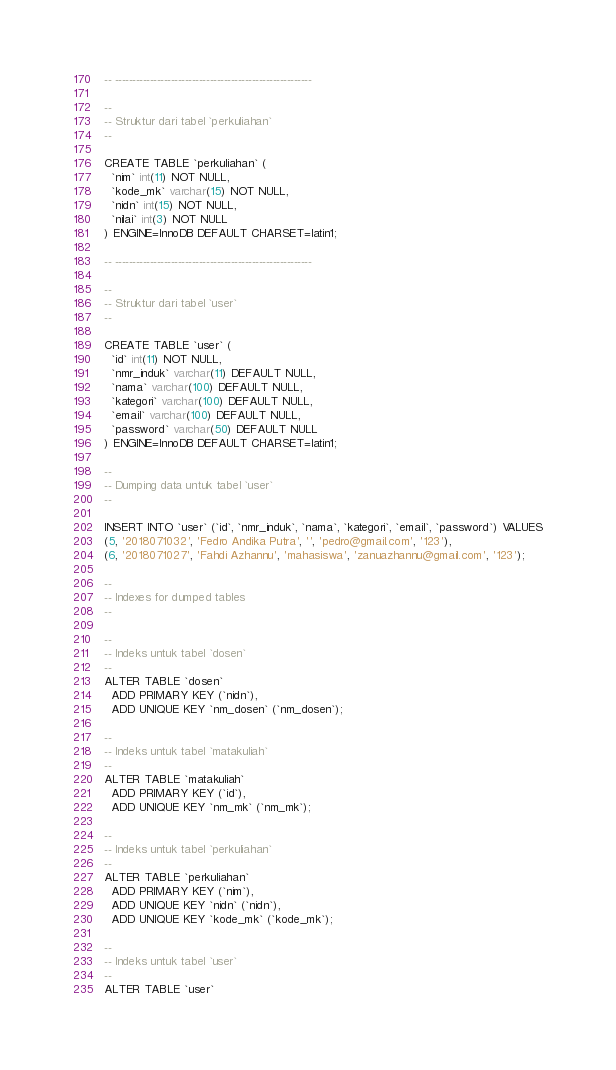Convert code to text. <code><loc_0><loc_0><loc_500><loc_500><_SQL_>-- --------------------------------------------------------

--
-- Struktur dari tabel `perkuliahan`
--

CREATE TABLE `perkuliahan` (
  `nim` int(11) NOT NULL,
  `kode_mk` varchar(15) NOT NULL,
  `nidn` int(15) NOT NULL,
  `nilai` int(3) NOT NULL
) ENGINE=InnoDB DEFAULT CHARSET=latin1;

-- --------------------------------------------------------

--
-- Struktur dari tabel `user`
--

CREATE TABLE `user` (
  `id` int(11) NOT NULL,
  `nmr_induk` varchar(11) DEFAULT NULL,
  `nama` varchar(100) DEFAULT NULL,
  `kategori` varchar(100) DEFAULT NULL,
  `email` varchar(100) DEFAULT NULL,
  `password` varchar(50) DEFAULT NULL
) ENGINE=InnoDB DEFAULT CHARSET=latin1;

--
-- Dumping data untuk tabel `user`
--

INSERT INTO `user` (`id`, `nmr_induk`, `nama`, `kategori`, `email`, `password`) VALUES
(5, '2018071032', 'Fedro Andika Putra', '', 'pedro@gmail.com', '123'),
(6, '2018071027', 'Fahdi Azhannu', 'mahasiswa', 'zanuazhannu@gmail.com', '123');

--
-- Indexes for dumped tables
--

--
-- Indeks untuk tabel `dosen`
--
ALTER TABLE `dosen`
  ADD PRIMARY KEY (`nidn`),
  ADD UNIQUE KEY `nm_dosen` (`nm_dosen`);

--
-- Indeks untuk tabel `matakuliah`
--
ALTER TABLE `matakuliah`
  ADD PRIMARY KEY (`id`),
  ADD UNIQUE KEY `nm_mk` (`nm_mk`);

--
-- Indeks untuk tabel `perkuliahan`
--
ALTER TABLE `perkuliahan`
  ADD PRIMARY KEY (`nim`),
  ADD UNIQUE KEY `nidn` (`nidn`),
  ADD UNIQUE KEY `kode_mk` (`kode_mk`);

--
-- Indeks untuk tabel `user`
--
ALTER TABLE `user`</code> 